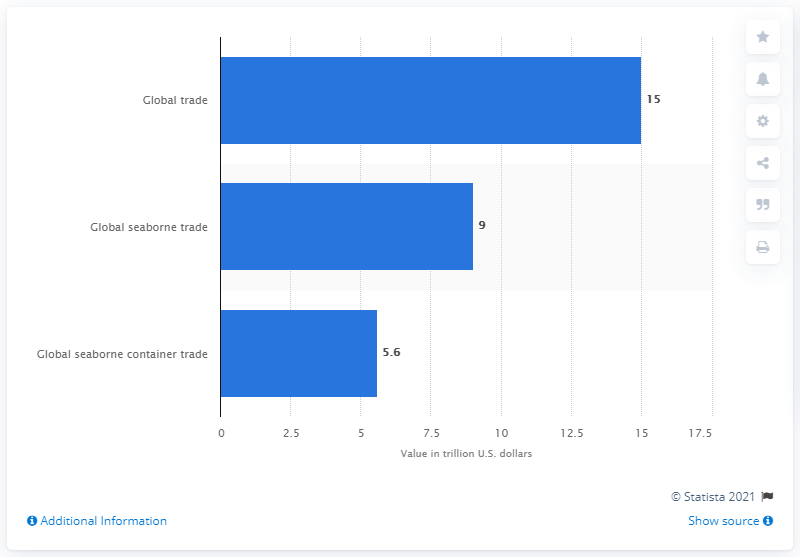Give some essential details in this illustration. The average of all the bars is 9.86. What is the value of global trade? It is 15%. 